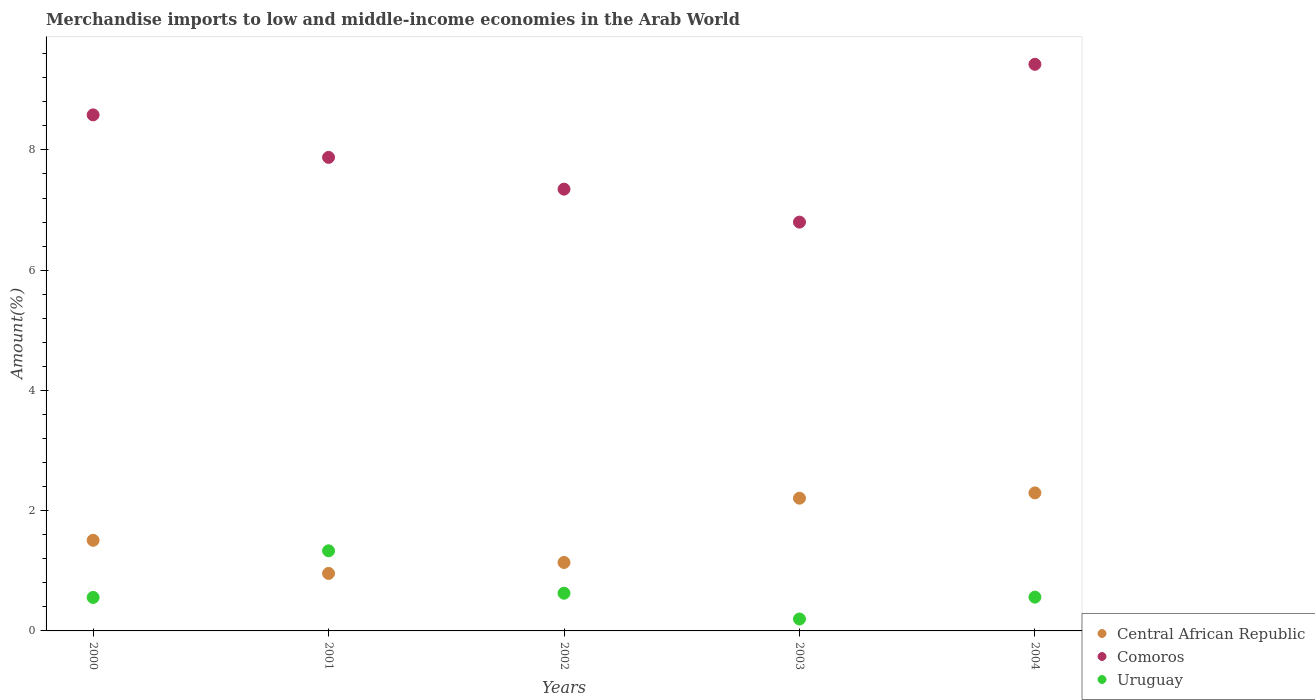How many different coloured dotlines are there?
Your answer should be very brief. 3. Is the number of dotlines equal to the number of legend labels?
Provide a succinct answer. Yes. What is the percentage of amount earned from merchandise imports in Comoros in 2001?
Your answer should be compact. 7.88. Across all years, what is the maximum percentage of amount earned from merchandise imports in Uruguay?
Give a very brief answer. 1.33. Across all years, what is the minimum percentage of amount earned from merchandise imports in Central African Republic?
Give a very brief answer. 0.96. What is the total percentage of amount earned from merchandise imports in Uruguay in the graph?
Provide a short and direct response. 3.28. What is the difference between the percentage of amount earned from merchandise imports in Uruguay in 2001 and that in 2002?
Keep it short and to the point. 0.71. What is the difference between the percentage of amount earned from merchandise imports in Central African Republic in 2004 and the percentage of amount earned from merchandise imports in Comoros in 2003?
Offer a terse response. -4.5. What is the average percentage of amount earned from merchandise imports in Central African Republic per year?
Provide a succinct answer. 1.62. In the year 2002, what is the difference between the percentage of amount earned from merchandise imports in Central African Republic and percentage of amount earned from merchandise imports in Uruguay?
Offer a terse response. 0.51. In how many years, is the percentage of amount earned from merchandise imports in Uruguay greater than 3.2 %?
Provide a short and direct response. 0. What is the ratio of the percentage of amount earned from merchandise imports in Central African Republic in 2000 to that in 2002?
Provide a succinct answer. 1.32. Is the percentage of amount earned from merchandise imports in Comoros in 2001 less than that in 2004?
Your answer should be compact. Yes. What is the difference between the highest and the second highest percentage of amount earned from merchandise imports in Central African Republic?
Your answer should be compact. 0.09. What is the difference between the highest and the lowest percentage of amount earned from merchandise imports in Comoros?
Provide a succinct answer. 2.62. Is the sum of the percentage of amount earned from merchandise imports in Comoros in 2003 and 2004 greater than the maximum percentage of amount earned from merchandise imports in Central African Republic across all years?
Make the answer very short. Yes. Is the percentage of amount earned from merchandise imports in Uruguay strictly greater than the percentage of amount earned from merchandise imports in Central African Republic over the years?
Your response must be concise. No. How many dotlines are there?
Offer a very short reply. 3. How many years are there in the graph?
Give a very brief answer. 5. What is the difference between two consecutive major ticks on the Y-axis?
Your response must be concise. 2. Does the graph contain grids?
Provide a short and direct response. No. Where does the legend appear in the graph?
Provide a short and direct response. Bottom right. What is the title of the graph?
Provide a succinct answer. Merchandise imports to low and middle-income economies in the Arab World. Does "Uganda" appear as one of the legend labels in the graph?
Make the answer very short. No. What is the label or title of the Y-axis?
Ensure brevity in your answer.  Amount(%). What is the Amount(%) in Central African Republic in 2000?
Provide a succinct answer. 1.51. What is the Amount(%) of Comoros in 2000?
Give a very brief answer. 8.58. What is the Amount(%) in Uruguay in 2000?
Provide a succinct answer. 0.56. What is the Amount(%) of Central African Republic in 2001?
Your answer should be compact. 0.96. What is the Amount(%) of Comoros in 2001?
Provide a short and direct response. 7.88. What is the Amount(%) in Uruguay in 2001?
Offer a very short reply. 1.33. What is the Amount(%) in Central African Republic in 2002?
Ensure brevity in your answer.  1.14. What is the Amount(%) of Comoros in 2002?
Keep it short and to the point. 7.35. What is the Amount(%) in Uruguay in 2002?
Make the answer very short. 0.63. What is the Amount(%) of Central African Republic in 2003?
Your answer should be compact. 2.21. What is the Amount(%) in Comoros in 2003?
Keep it short and to the point. 6.8. What is the Amount(%) in Uruguay in 2003?
Keep it short and to the point. 0.2. What is the Amount(%) in Central African Republic in 2004?
Make the answer very short. 2.3. What is the Amount(%) in Comoros in 2004?
Keep it short and to the point. 9.42. What is the Amount(%) of Uruguay in 2004?
Make the answer very short. 0.56. Across all years, what is the maximum Amount(%) in Central African Republic?
Keep it short and to the point. 2.3. Across all years, what is the maximum Amount(%) of Comoros?
Keep it short and to the point. 9.42. Across all years, what is the maximum Amount(%) of Uruguay?
Make the answer very short. 1.33. Across all years, what is the minimum Amount(%) in Central African Republic?
Offer a terse response. 0.96. Across all years, what is the minimum Amount(%) in Comoros?
Provide a succinct answer. 6.8. Across all years, what is the minimum Amount(%) in Uruguay?
Provide a succinct answer. 0.2. What is the total Amount(%) of Central African Republic in the graph?
Provide a short and direct response. 8.11. What is the total Amount(%) of Comoros in the graph?
Provide a short and direct response. 40.03. What is the total Amount(%) in Uruguay in the graph?
Your answer should be compact. 3.28. What is the difference between the Amount(%) in Central African Republic in 2000 and that in 2001?
Provide a succinct answer. 0.55. What is the difference between the Amount(%) of Comoros in 2000 and that in 2001?
Your answer should be very brief. 0.71. What is the difference between the Amount(%) in Uruguay in 2000 and that in 2001?
Your answer should be very brief. -0.78. What is the difference between the Amount(%) in Central African Republic in 2000 and that in 2002?
Offer a very short reply. 0.37. What is the difference between the Amount(%) in Comoros in 2000 and that in 2002?
Your response must be concise. 1.24. What is the difference between the Amount(%) in Uruguay in 2000 and that in 2002?
Your answer should be compact. -0.07. What is the difference between the Amount(%) in Central African Republic in 2000 and that in 2003?
Provide a succinct answer. -0.7. What is the difference between the Amount(%) in Comoros in 2000 and that in 2003?
Keep it short and to the point. 1.78. What is the difference between the Amount(%) in Uruguay in 2000 and that in 2003?
Offer a very short reply. 0.36. What is the difference between the Amount(%) of Central African Republic in 2000 and that in 2004?
Provide a short and direct response. -0.79. What is the difference between the Amount(%) in Comoros in 2000 and that in 2004?
Give a very brief answer. -0.84. What is the difference between the Amount(%) in Uruguay in 2000 and that in 2004?
Offer a very short reply. -0.01. What is the difference between the Amount(%) of Central African Republic in 2001 and that in 2002?
Provide a short and direct response. -0.18. What is the difference between the Amount(%) of Comoros in 2001 and that in 2002?
Your response must be concise. 0.53. What is the difference between the Amount(%) in Uruguay in 2001 and that in 2002?
Your response must be concise. 0.71. What is the difference between the Amount(%) of Central African Republic in 2001 and that in 2003?
Your answer should be very brief. -1.25. What is the difference between the Amount(%) in Comoros in 2001 and that in 2003?
Ensure brevity in your answer.  1.08. What is the difference between the Amount(%) in Uruguay in 2001 and that in 2003?
Your answer should be very brief. 1.13. What is the difference between the Amount(%) of Central African Republic in 2001 and that in 2004?
Make the answer very short. -1.34. What is the difference between the Amount(%) in Comoros in 2001 and that in 2004?
Give a very brief answer. -1.55. What is the difference between the Amount(%) in Uruguay in 2001 and that in 2004?
Provide a succinct answer. 0.77. What is the difference between the Amount(%) of Central African Republic in 2002 and that in 2003?
Your answer should be compact. -1.07. What is the difference between the Amount(%) of Comoros in 2002 and that in 2003?
Give a very brief answer. 0.55. What is the difference between the Amount(%) of Uruguay in 2002 and that in 2003?
Provide a short and direct response. 0.43. What is the difference between the Amount(%) of Central African Republic in 2002 and that in 2004?
Ensure brevity in your answer.  -1.16. What is the difference between the Amount(%) of Comoros in 2002 and that in 2004?
Make the answer very short. -2.08. What is the difference between the Amount(%) in Uruguay in 2002 and that in 2004?
Provide a succinct answer. 0.07. What is the difference between the Amount(%) of Central African Republic in 2003 and that in 2004?
Your response must be concise. -0.09. What is the difference between the Amount(%) in Comoros in 2003 and that in 2004?
Provide a succinct answer. -2.62. What is the difference between the Amount(%) of Uruguay in 2003 and that in 2004?
Offer a terse response. -0.36. What is the difference between the Amount(%) of Central African Republic in 2000 and the Amount(%) of Comoros in 2001?
Your answer should be very brief. -6.37. What is the difference between the Amount(%) of Central African Republic in 2000 and the Amount(%) of Uruguay in 2001?
Give a very brief answer. 0.17. What is the difference between the Amount(%) in Comoros in 2000 and the Amount(%) in Uruguay in 2001?
Offer a terse response. 7.25. What is the difference between the Amount(%) in Central African Republic in 2000 and the Amount(%) in Comoros in 2002?
Offer a terse response. -5.84. What is the difference between the Amount(%) of Central African Republic in 2000 and the Amount(%) of Uruguay in 2002?
Your answer should be very brief. 0.88. What is the difference between the Amount(%) of Comoros in 2000 and the Amount(%) of Uruguay in 2002?
Your answer should be very brief. 7.96. What is the difference between the Amount(%) of Central African Republic in 2000 and the Amount(%) of Comoros in 2003?
Ensure brevity in your answer.  -5.29. What is the difference between the Amount(%) in Central African Republic in 2000 and the Amount(%) in Uruguay in 2003?
Provide a succinct answer. 1.31. What is the difference between the Amount(%) of Comoros in 2000 and the Amount(%) of Uruguay in 2003?
Offer a very short reply. 8.38. What is the difference between the Amount(%) in Central African Republic in 2000 and the Amount(%) in Comoros in 2004?
Your answer should be compact. -7.92. What is the difference between the Amount(%) in Central African Republic in 2000 and the Amount(%) in Uruguay in 2004?
Ensure brevity in your answer.  0.95. What is the difference between the Amount(%) in Comoros in 2000 and the Amount(%) in Uruguay in 2004?
Make the answer very short. 8.02. What is the difference between the Amount(%) in Central African Republic in 2001 and the Amount(%) in Comoros in 2002?
Your answer should be very brief. -6.39. What is the difference between the Amount(%) in Central African Republic in 2001 and the Amount(%) in Uruguay in 2002?
Make the answer very short. 0.33. What is the difference between the Amount(%) in Comoros in 2001 and the Amount(%) in Uruguay in 2002?
Your answer should be very brief. 7.25. What is the difference between the Amount(%) of Central African Republic in 2001 and the Amount(%) of Comoros in 2003?
Provide a succinct answer. -5.84. What is the difference between the Amount(%) of Central African Republic in 2001 and the Amount(%) of Uruguay in 2003?
Provide a short and direct response. 0.76. What is the difference between the Amount(%) in Comoros in 2001 and the Amount(%) in Uruguay in 2003?
Ensure brevity in your answer.  7.68. What is the difference between the Amount(%) in Central African Republic in 2001 and the Amount(%) in Comoros in 2004?
Your response must be concise. -8.47. What is the difference between the Amount(%) of Central African Republic in 2001 and the Amount(%) of Uruguay in 2004?
Provide a short and direct response. 0.39. What is the difference between the Amount(%) in Comoros in 2001 and the Amount(%) in Uruguay in 2004?
Keep it short and to the point. 7.31. What is the difference between the Amount(%) of Central African Republic in 2002 and the Amount(%) of Comoros in 2003?
Give a very brief answer. -5.66. What is the difference between the Amount(%) in Central African Republic in 2002 and the Amount(%) in Uruguay in 2003?
Give a very brief answer. 0.94. What is the difference between the Amount(%) of Comoros in 2002 and the Amount(%) of Uruguay in 2003?
Your answer should be very brief. 7.15. What is the difference between the Amount(%) of Central African Republic in 2002 and the Amount(%) of Comoros in 2004?
Give a very brief answer. -8.29. What is the difference between the Amount(%) in Central African Republic in 2002 and the Amount(%) in Uruguay in 2004?
Keep it short and to the point. 0.58. What is the difference between the Amount(%) of Comoros in 2002 and the Amount(%) of Uruguay in 2004?
Give a very brief answer. 6.79. What is the difference between the Amount(%) in Central African Republic in 2003 and the Amount(%) in Comoros in 2004?
Give a very brief answer. -7.22. What is the difference between the Amount(%) of Central African Republic in 2003 and the Amount(%) of Uruguay in 2004?
Offer a very short reply. 1.65. What is the difference between the Amount(%) of Comoros in 2003 and the Amount(%) of Uruguay in 2004?
Provide a short and direct response. 6.24. What is the average Amount(%) of Central African Republic per year?
Your answer should be very brief. 1.62. What is the average Amount(%) of Comoros per year?
Your answer should be very brief. 8.01. What is the average Amount(%) in Uruguay per year?
Keep it short and to the point. 0.66. In the year 2000, what is the difference between the Amount(%) of Central African Republic and Amount(%) of Comoros?
Give a very brief answer. -7.08. In the year 2000, what is the difference between the Amount(%) of Central African Republic and Amount(%) of Uruguay?
Make the answer very short. 0.95. In the year 2000, what is the difference between the Amount(%) of Comoros and Amount(%) of Uruguay?
Your answer should be compact. 8.03. In the year 2001, what is the difference between the Amount(%) of Central African Republic and Amount(%) of Comoros?
Your response must be concise. -6.92. In the year 2001, what is the difference between the Amount(%) in Central African Republic and Amount(%) in Uruguay?
Offer a terse response. -0.38. In the year 2001, what is the difference between the Amount(%) in Comoros and Amount(%) in Uruguay?
Your response must be concise. 6.54. In the year 2002, what is the difference between the Amount(%) of Central African Republic and Amount(%) of Comoros?
Make the answer very short. -6.21. In the year 2002, what is the difference between the Amount(%) of Central African Republic and Amount(%) of Uruguay?
Keep it short and to the point. 0.51. In the year 2002, what is the difference between the Amount(%) of Comoros and Amount(%) of Uruguay?
Your answer should be very brief. 6.72. In the year 2003, what is the difference between the Amount(%) of Central African Republic and Amount(%) of Comoros?
Your response must be concise. -4.59. In the year 2003, what is the difference between the Amount(%) in Central African Republic and Amount(%) in Uruguay?
Provide a short and direct response. 2.01. In the year 2003, what is the difference between the Amount(%) of Comoros and Amount(%) of Uruguay?
Give a very brief answer. 6.6. In the year 2004, what is the difference between the Amount(%) of Central African Republic and Amount(%) of Comoros?
Provide a succinct answer. -7.13. In the year 2004, what is the difference between the Amount(%) in Central African Republic and Amount(%) in Uruguay?
Your answer should be very brief. 1.73. In the year 2004, what is the difference between the Amount(%) of Comoros and Amount(%) of Uruguay?
Ensure brevity in your answer.  8.86. What is the ratio of the Amount(%) in Central African Republic in 2000 to that in 2001?
Ensure brevity in your answer.  1.58. What is the ratio of the Amount(%) in Comoros in 2000 to that in 2001?
Give a very brief answer. 1.09. What is the ratio of the Amount(%) in Uruguay in 2000 to that in 2001?
Provide a short and direct response. 0.42. What is the ratio of the Amount(%) in Central African Republic in 2000 to that in 2002?
Offer a terse response. 1.32. What is the ratio of the Amount(%) in Comoros in 2000 to that in 2002?
Give a very brief answer. 1.17. What is the ratio of the Amount(%) of Uruguay in 2000 to that in 2002?
Keep it short and to the point. 0.89. What is the ratio of the Amount(%) of Central African Republic in 2000 to that in 2003?
Your answer should be compact. 0.68. What is the ratio of the Amount(%) of Comoros in 2000 to that in 2003?
Your response must be concise. 1.26. What is the ratio of the Amount(%) in Uruguay in 2000 to that in 2003?
Provide a short and direct response. 2.81. What is the ratio of the Amount(%) in Central African Republic in 2000 to that in 2004?
Your response must be concise. 0.66. What is the ratio of the Amount(%) in Comoros in 2000 to that in 2004?
Provide a short and direct response. 0.91. What is the ratio of the Amount(%) in Uruguay in 2000 to that in 2004?
Provide a short and direct response. 0.99. What is the ratio of the Amount(%) of Central African Republic in 2001 to that in 2002?
Offer a very short reply. 0.84. What is the ratio of the Amount(%) in Comoros in 2001 to that in 2002?
Your answer should be compact. 1.07. What is the ratio of the Amount(%) in Uruguay in 2001 to that in 2002?
Your answer should be compact. 2.12. What is the ratio of the Amount(%) in Central African Republic in 2001 to that in 2003?
Offer a very short reply. 0.43. What is the ratio of the Amount(%) of Comoros in 2001 to that in 2003?
Your answer should be compact. 1.16. What is the ratio of the Amount(%) of Uruguay in 2001 to that in 2003?
Ensure brevity in your answer.  6.72. What is the ratio of the Amount(%) of Central African Republic in 2001 to that in 2004?
Your response must be concise. 0.42. What is the ratio of the Amount(%) of Comoros in 2001 to that in 2004?
Provide a succinct answer. 0.84. What is the ratio of the Amount(%) in Uruguay in 2001 to that in 2004?
Keep it short and to the point. 2.37. What is the ratio of the Amount(%) in Central African Republic in 2002 to that in 2003?
Offer a very short reply. 0.52. What is the ratio of the Amount(%) in Comoros in 2002 to that in 2003?
Offer a terse response. 1.08. What is the ratio of the Amount(%) of Uruguay in 2002 to that in 2003?
Ensure brevity in your answer.  3.16. What is the ratio of the Amount(%) in Central African Republic in 2002 to that in 2004?
Provide a succinct answer. 0.5. What is the ratio of the Amount(%) in Comoros in 2002 to that in 2004?
Offer a very short reply. 0.78. What is the ratio of the Amount(%) in Uruguay in 2002 to that in 2004?
Offer a terse response. 1.12. What is the ratio of the Amount(%) of Central African Republic in 2003 to that in 2004?
Offer a terse response. 0.96. What is the ratio of the Amount(%) in Comoros in 2003 to that in 2004?
Your response must be concise. 0.72. What is the ratio of the Amount(%) in Uruguay in 2003 to that in 2004?
Provide a succinct answer. 0.35. What is the difference between the highest and the second highest Amount(%) in Central African Republic?
Ensure brevity in your answer.  0.09. What is the difference between the highest and the second highest Amount(%) of Comoros?
Offer a very short reply. 0.84. What is the difference between the highest and the second highest Amount(%) of Uruguay?
Offer a very short reply. 0.71. What is the difference between the highest and the lowest Amount(%) of Central African Republic?
Keep it short and to the point. 1.34. What is the difference between the highest and the lowest Amount(%) of Comoros?
Keep it short and to the point. 2.62. What is the difference between the highest and the lowest Amount(%) in Uruguay?
Offer a very short reply. 1.13. 